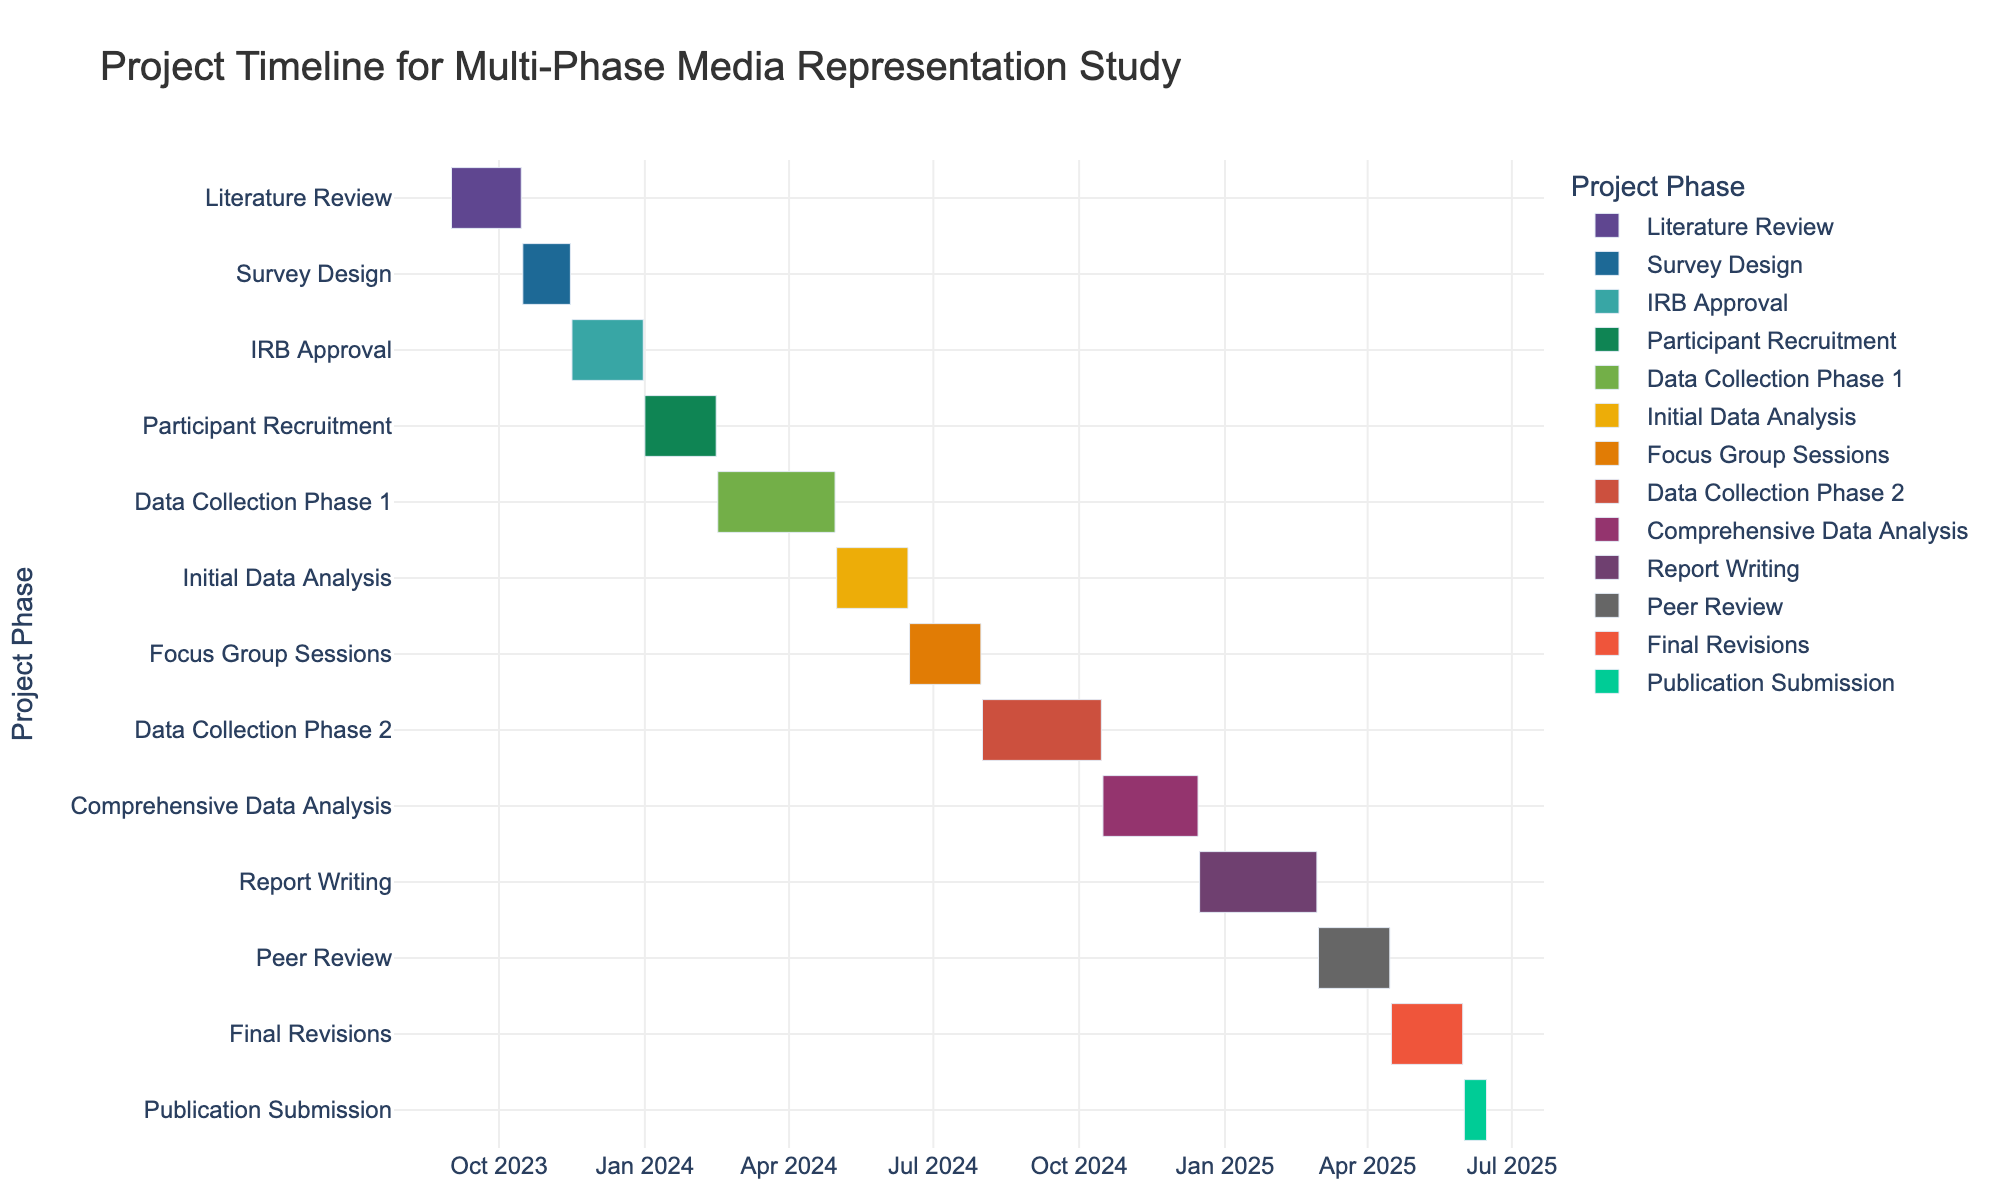What's the title of the figure? The title is usually prominently displayed at the top of the figure. It provides a high-level overview of what the figure represents. Look at the top center of the chart.
Answer: Project Timeline for Multi-Phase Media Representation Study Which task has the longest duration? To find the task with the longest duration, look at the lengths of the bars on the Gantt chart. The longest bar represents the task with the longest duration.
Answer: Comprehensive Data Analysis During what months does Participant Recruitment take place? Identify the start and end points of the bar labeled "Participant Recruitment" on the x-axis, which represents the timeline. The task spans from January 2024 to mid-February 2024.
Answer: January and February 2024 What is the shortest task in the project timeline? To determine the shortest task, compare the lengths of the bars for each task. The shortest bar corresponds to the shortest task duration.
Answer: Publication Submission Which two tasks are carried out consecutively without any overlap? Look at the sequence of the bars on the timeline. Identify consecutive tasks where the end date of one task is immediately followed by the start date of the next task. "Peer Review" ends on April 15, 2025, and "Final Revisions" start on April 16, 2025.
Answer: Peer Review and Final Revisions Which tasks are active during April 2024? Find the bars that span across April 2024 on the timeline. Identify each task that overlaps with that month. "Data Collection Phase 1" (active in April 2024) and "Initial Data Analysis" (begins in May 2024) are the bars to consider.
Answer: Data Collection Phase 1 How long after the completion of IRB Approval does the Participant Recruitment commence? Determine the end date of "IRB Approval" and the start date of "Participant Recruitment". Calculate the number of days between these dates. IRB Approval ends on December 31, 2023, and Participant Recruitment starts on January 1, 2024.
Answer: 1 day What is the total duration of all data collection phases combined? Sum the durations of "Data Collection Phase 1" and "Data Collection Phase 2". Convert each duration from its start and end dates to days and add them together. "Data Collection Phase 1" runs from February 16, 2024, to April 30, 2024 (74 days), and "Data Collection Phase 2" runs from August 1, 2024, to October 15, 2024 (76 days).
Answer: 150 days 